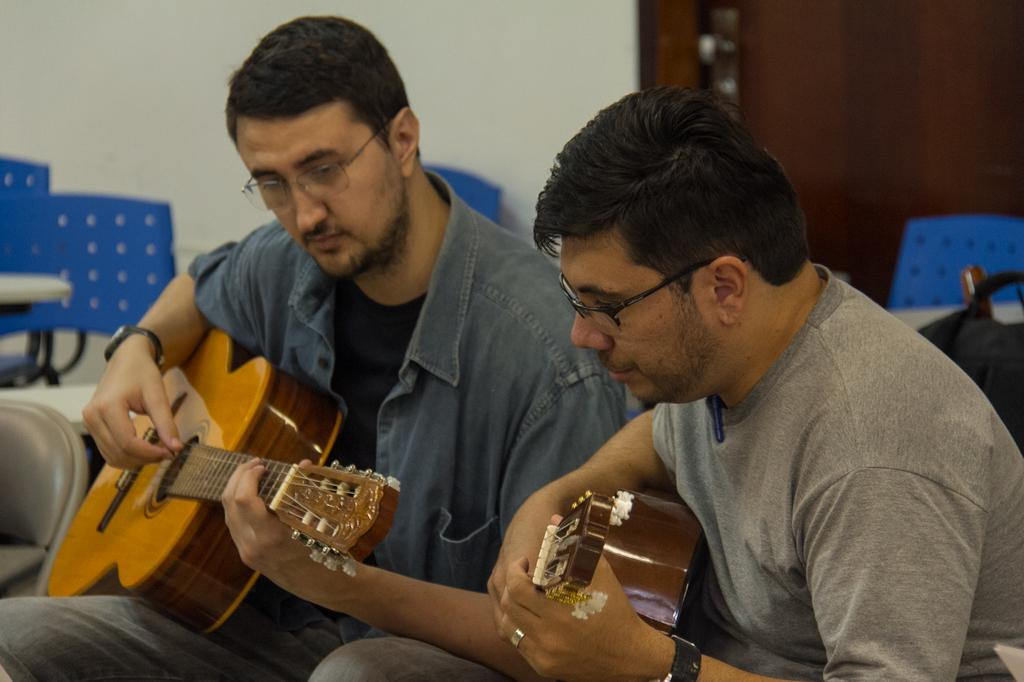What type of structure can be seen in the background of the image? There is a door and a wall in the background of the image. What objects are present in the background of the image? There are chairs in the background of the image. How many people are in the image? There are two men in the image. What are the men wearing? Both men are wearing spectacles. What are the men doing in the image? Both men are playing guitar with their hands. What accessory are the men wearing on their wrists? Both men are wearing watches. What type of secretary can be seen in the image? There is no secretary present in the image. What team are the men playing for in the image? There is no team or sports activity depicted in the image. 